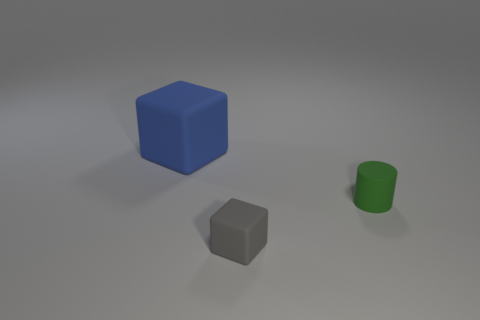There is a gray matte object that is the same size as the green object; what shape is it?
Ensure brevity in your answer.  Cube. How many rubber objects are both in front of the large matte thing and behind the small gray matte block?
Provide a succinct answer. 1. The blue object that is the same material as the gray object is what size?
Make the answer very short. Large. There is a object in front of the small cylinder; does it have the same size as the matte block to the left of the gray rubber cube?
Provide a succinct answer. No. What is the material of the gray block that is the same size as the green thing?
Offer a very short reply. Rubber. There is a object that is to the right of the big blue cube and to the left of the small green cylinder; what is its material?
Provide a short and direct response. Rubber. Are there any small purple cylinders?
Your answer should be very brief. No. Is there anything else that has the same shape as the green matte object?
Your response must be concise. No. What shape is the small rubber thing on the left side of the rubber object to the right of the small object that is left of the small green cylinder?
Provide a succinct answer. Cube. There is a green thing; what shape is it?
Provide a succinct answer. Cylinder. 